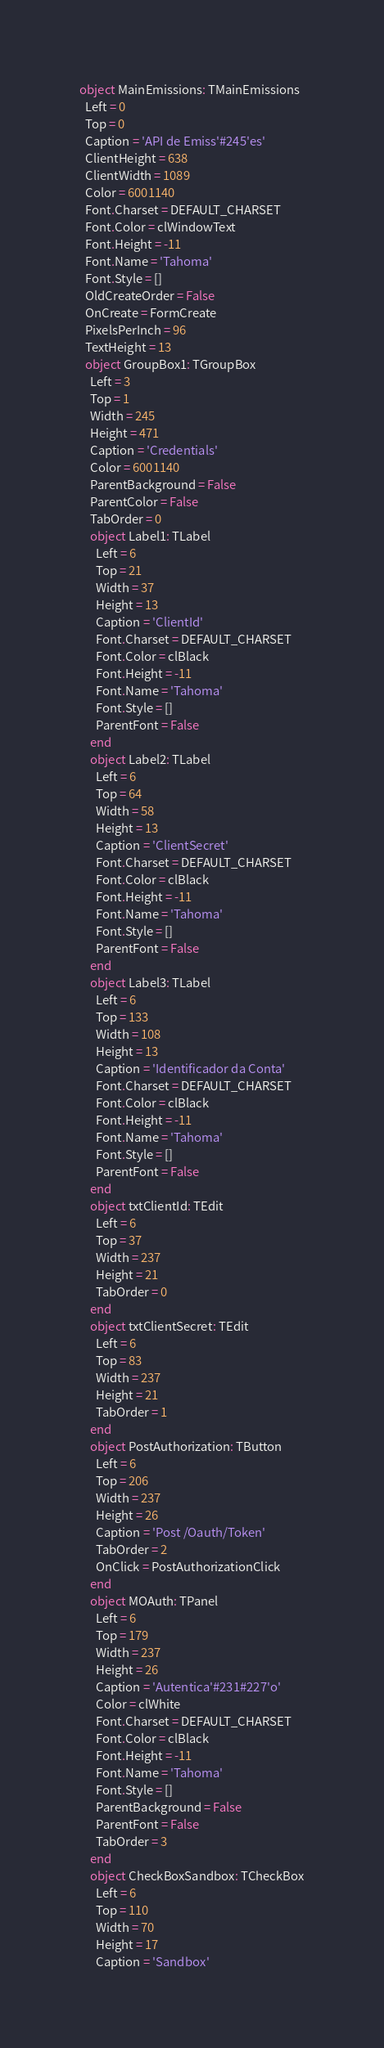<code> <loc_0><loc_0><loc_500><loc_500><_Pascal_>object MainEmissions: TMainEmissions
  Left = 0
  Top = 0
  Caption = 'API de Emiss'#245'es'
  ClientHeight = 638
  ClientWidth = 1089
  Color = 6001140
  Font.Charset = DEFAULT_CHARSET
  Font.Color = clWindowText
  Font.Height = -11
  Font.Name = 'Tahoma'
  Font.Style = []
  OldCreateOrder = False
  OnCreate = FormCreate
  PixelsPerInch = 96
  TextHeight = 13
  object GroupBox1: TGroupBox
    Left = 3
    Top = 1
    Width = 245
    Height = 471
    Caption = 'Credentials'
    Color = 6001140
    ParentBackground = False
    ParentColor = False
    TabOrder = 0
    object Label1: TLabel
      Left = 6
      Top = 21
      Width = 37
      Height = 13
      Caption = 'ClientId'
      Font.Charset = DEFAULT_CHARSET
      Font.Color = clBlack
      Font.Height = -11
      Font.Name = 'Tahoma'
      Font.Style = []
      ParentFont = False
    end
    object Label2: TLabel
      Left = 6
      Top = 64
      Width = 58
      Height = 13
      Caption = 'ClientSecret'
      Font.Charset = DEFAULT_CHARSET
      Font.Color = clBlack
      Font.Height = -11
      Font.Name = 'Tahoma'
      Font.Style = []
      ParentFont = False
    end
    object Label3: TLabel
      Left = 6
      Top = 133
      Width = 108
      Height = 13
      Caption = 'Identificador da Conta'
      Font.Charset = DEFAULT_CHARSET
      Font.Color = clBlack
      Font.Height = -11
      Font.Name = 'Tahoma'
      Font.Style = []
      ParentFont = False
    end
    object txtClientId: TEdit
      Left = 6
      Top = 37
      Width = 237
      Height = 21
      TabOrder = 0
    end
    object txtClientSecret: TEdit
      Left = 6
      Top = 83
      Width = 237
      Height = 21
      TabOrder = 1
    end
    object PostAuthorization: TButton
      Left = 6
      Top = 206
      Width = 237
      Height = 26
      Caption = 'Post /Oauth/Token'
      TabOrder = 2
      OnClick = PostAuthorizationClick
    end
    object MOAuth: TPanel
      Left = 6
      Top = 179
      Width = 237
      Height = 26
      Caption = 'Autentica'#231#227'o'
      Color = clWhite
      Font.Charset = DEFAULT_CHARSET
      Font.Color = clBlack
      Font.Height = -11
      Font.Name = 'Tahoma'
      Font.Style = []
      ParentBackground = False
      ParentFont = False
      TabOrder = 3
    end
    object CheckBoxSandbox: TCheckBox
      Left = 6
      Top = 110
      Width = 70
      Height = 17
      Caption = 'Sandbox'</code> 